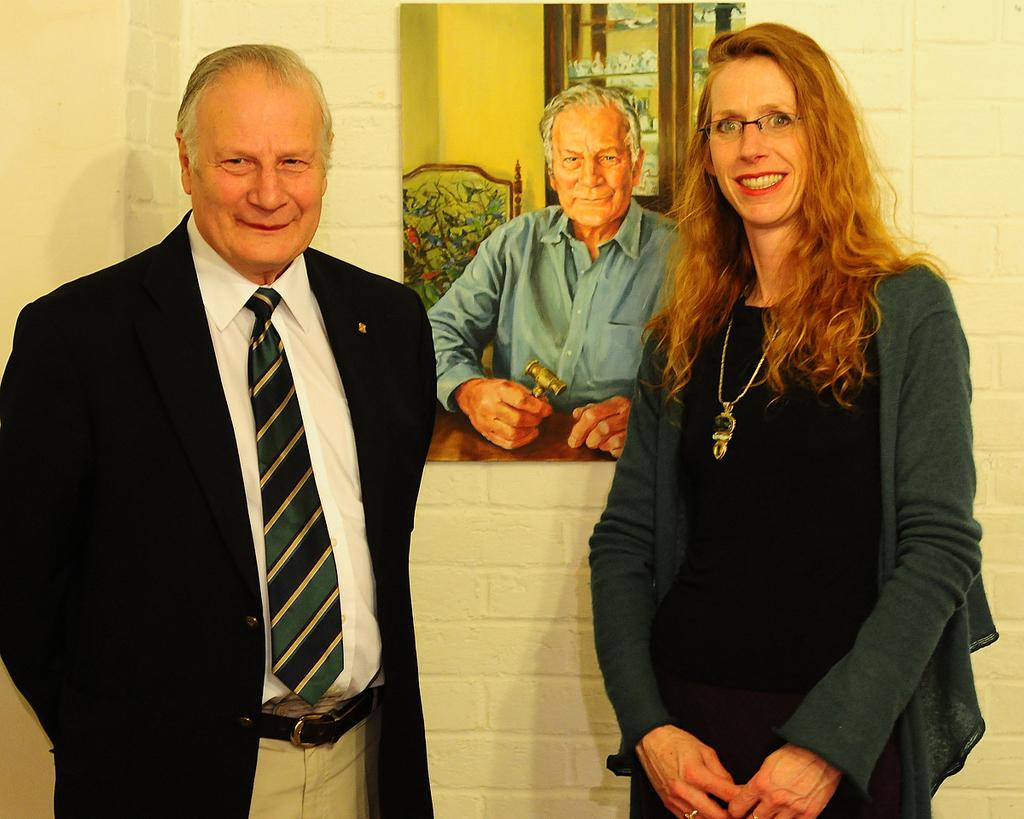How many people are in the image? There are two persons in the image. What is the background of the image? The persons are in front of a wall. What are the persons wearing? The persons are wearing clothes. What can be seen at the top of the image? There is a painting at the top of the image. What type of seed is being planted by the persons in the image? There is no seed or planting activity depicted in the image; it features two persons in front of a wall. What type of knowledge can be gained from the calculator in the image? There is no calculator present in the image. 